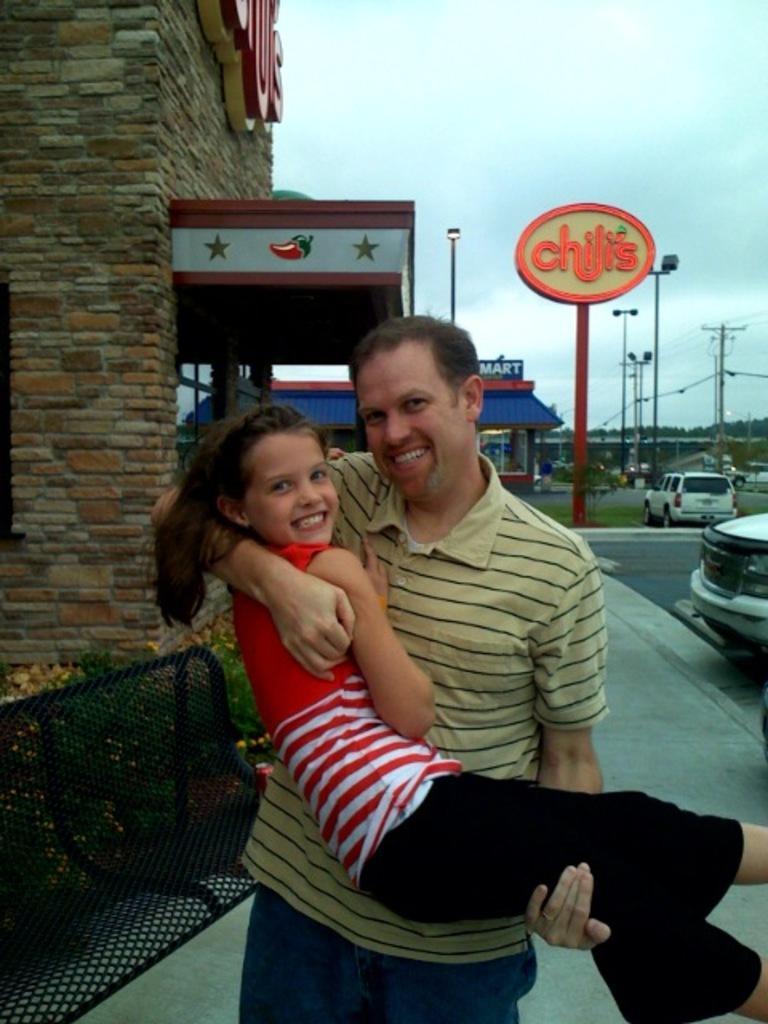Describe this image in one or two sentences. In this image we can see a man is standing. We can see a girl in the hands of the man. In the background, we can see buildings, poles, banners, plants, cars, road and pavement. At the top of the image, we can see the sky with clouds. We can see a bench and plants on the left side of the image. 